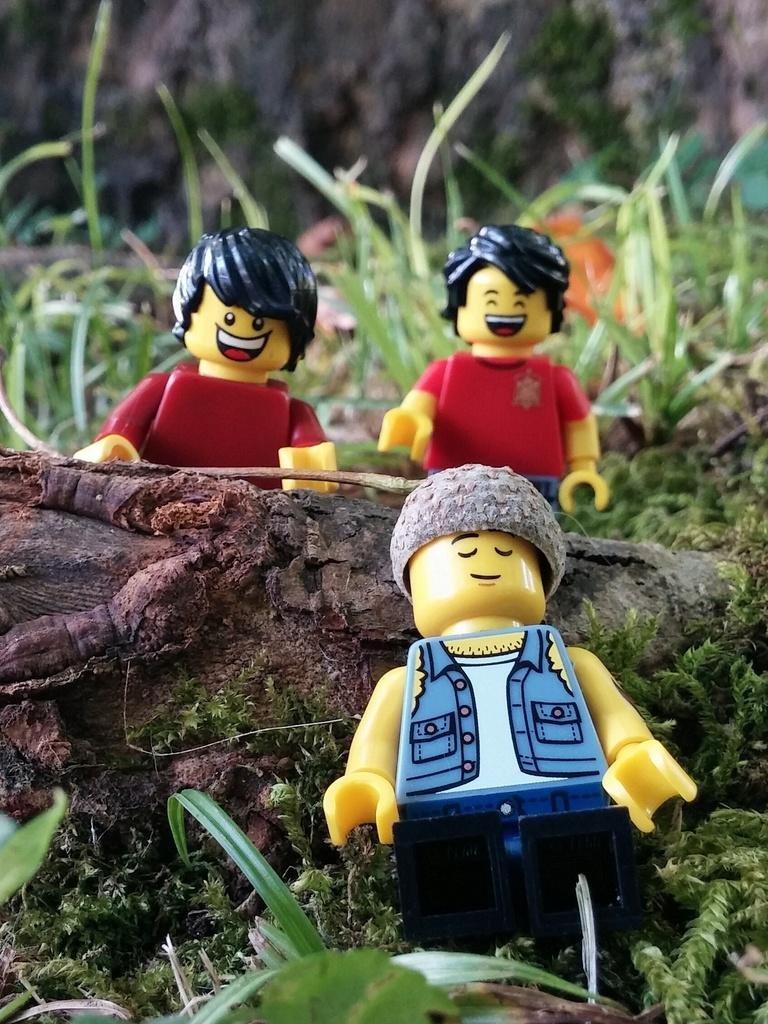What objects are present in the image? There are toys in the image. Where are the toys located? The toys are placed on the ground. What type of wire can be seen connecting the toys in the image? There is no wire connecting the toys in the image; they are simply placed on the ground. 